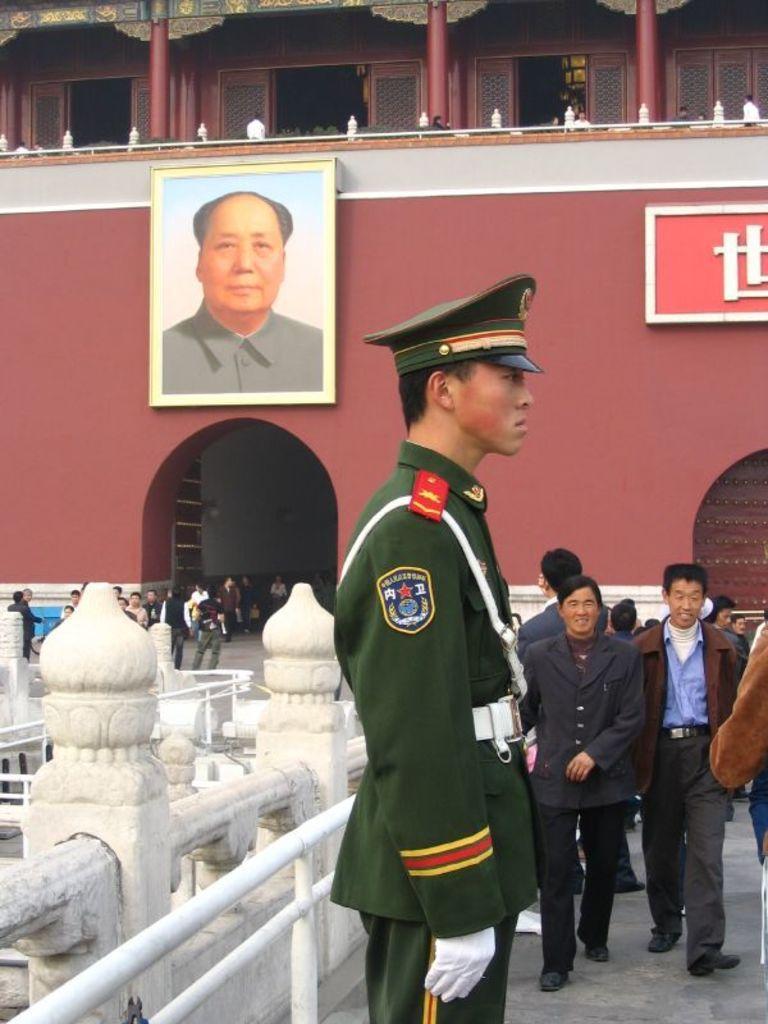Could you give a brief overview of what you see in this image? This image consists of many persons. In the front, we can see a man wearing a green color uniform along with a cap. In the background, we can see a frame on the wall. At the top, there are pillars. On the left, there is a railing. At the bottom, there is a floor. 